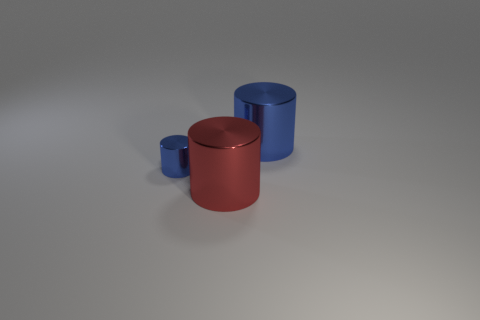There is a big cylinder that is the same color as the small object; what is it made of?
Ensure brevity in your answer.  Metal. There is a large metallic object that is behind the small shiny cylinder; does it have the same shape as the large red object?
Provide a succinct answer. Yes. How many things are big blue cylinders or blocks?
Give a very brief answer. 1. Is the material of the large cylinder in front of the big blue thing the same as the tiny blue cylinder?
Provide a short and direct response. Yes. How big is the red metallic cylinder?
Make the answer very short. Large. There is a big thing that is the same color as the tiny shiny object; what is its shape?
Keep it short and to the point. Cylinder. How many cylinders are small blue objects or red objects?
Provide a short and direct response. 2. Are there the same number of blue cylinders on the right side of the big blue metallic object and small blue metallic cylinders behind the tiny object?
Offer a terse response. Yes. There is a red metallic thing that is the same shape as the big blue metallic object; what size is it?
Your answer should be compact. Large. How big is the thing that is in front of the big blue cylinder and right of the tiny blue metallic thing?
Your answer should be compact. Large. 